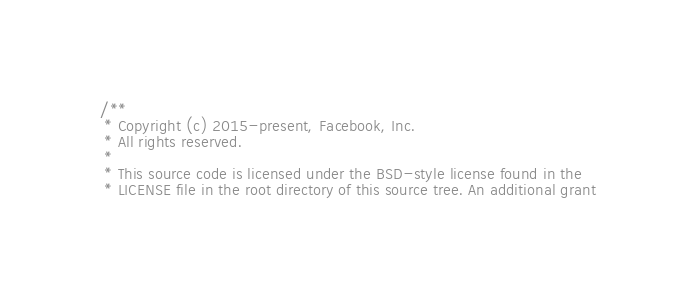Convert code to text. <code><loc_0><loc_0><loc_500><loc_500><_ObjectiveC_>/**
 * Copyright (c) 2015-present, Facebook, Inc.
 * All rights reserved.
 *
 * This source code is licensed under the BSD-style license found in the
 * LICENSE file in the root directory of this source tree. An additional grant</code> 